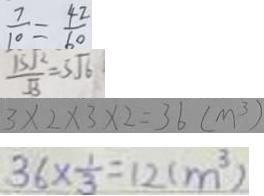<formula> <loc_0><loc_0><loc_500><loc_500>\frac { 7 } { 1 0 } = \frac { 4 2 } { 6 0 } 
 \frac { 1 5 \sqrt { 2 } } { \sqrt { 3 } } = 5 \sqrt { 6 } 
 3 \times 2 \times 3 \times 2 = 3 6 ( m ^ { 3 } ) 
 3 6 \times \frac { 1 } { 3 } = 1 2 ( m ^ { 3 } )</formula> 